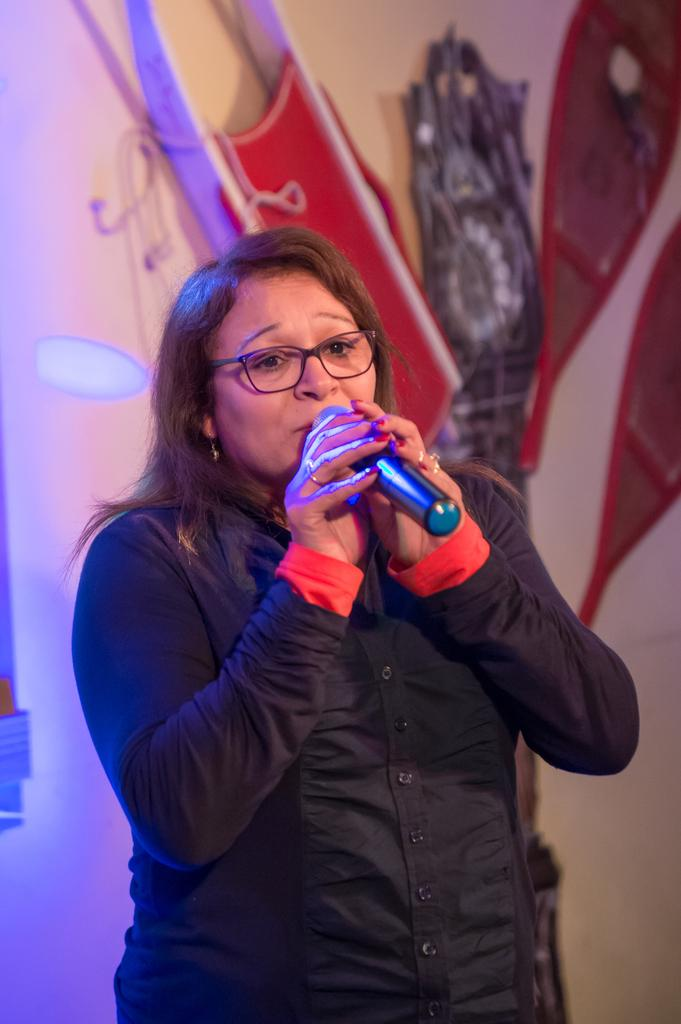Who is the main subject in the image? There is a lady in the image. What is the lady holding in her hands? The lady is holding a mic in both her hands. What can be seen in the background of the image? There are objects attached to the wall in the background of the image. Can you see a tramp in the image? No, there is no tramp present in the image. What type of pencil is the lady using to write with in the image? There is no pencil visible in the image, and the lady is holding a mic, not a pencil. 